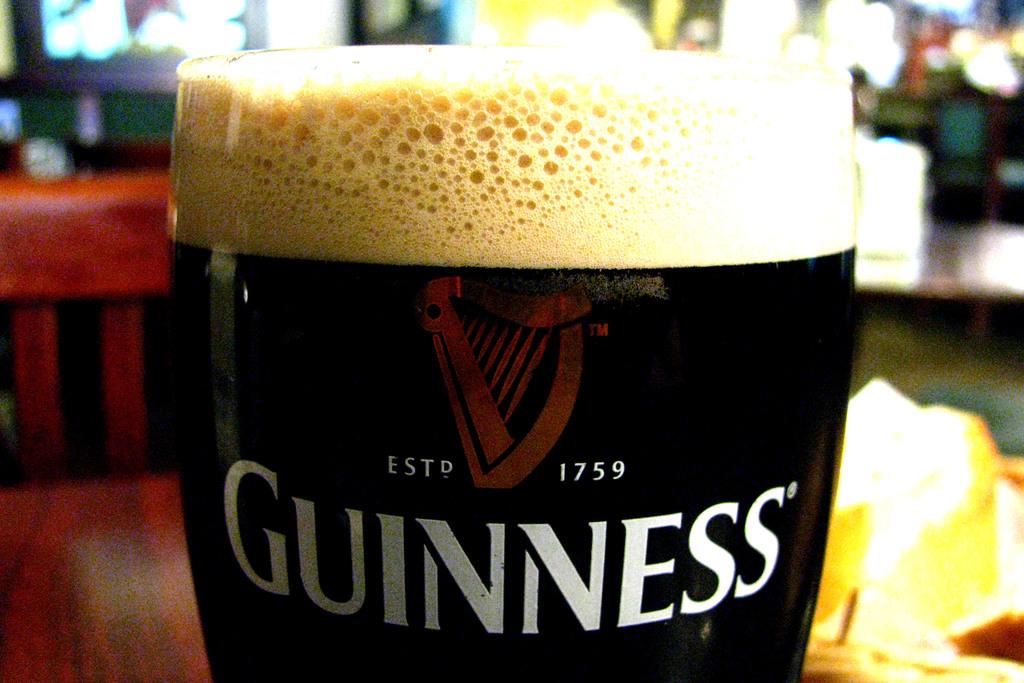When was guinness first established?
Offer a very short reply. 1759. What beer is this?
Your answer should be very brief. Guinness. 